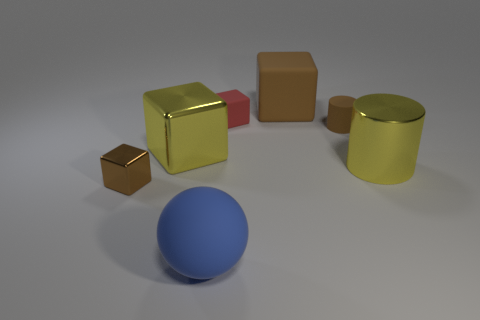What does the texture of the objects in the image suggest about the material they might be made of? The objects present a variety of textures: the shininess of the yellow cube suggests a polished surface, possibly a metallic or plastic material, while the brown block and blue sphere's matte finishes hint at a surface that could be made of wood or a non-reflective painted material. The yellow cylinder also has a matte texture, suggesting a similar constitution. 